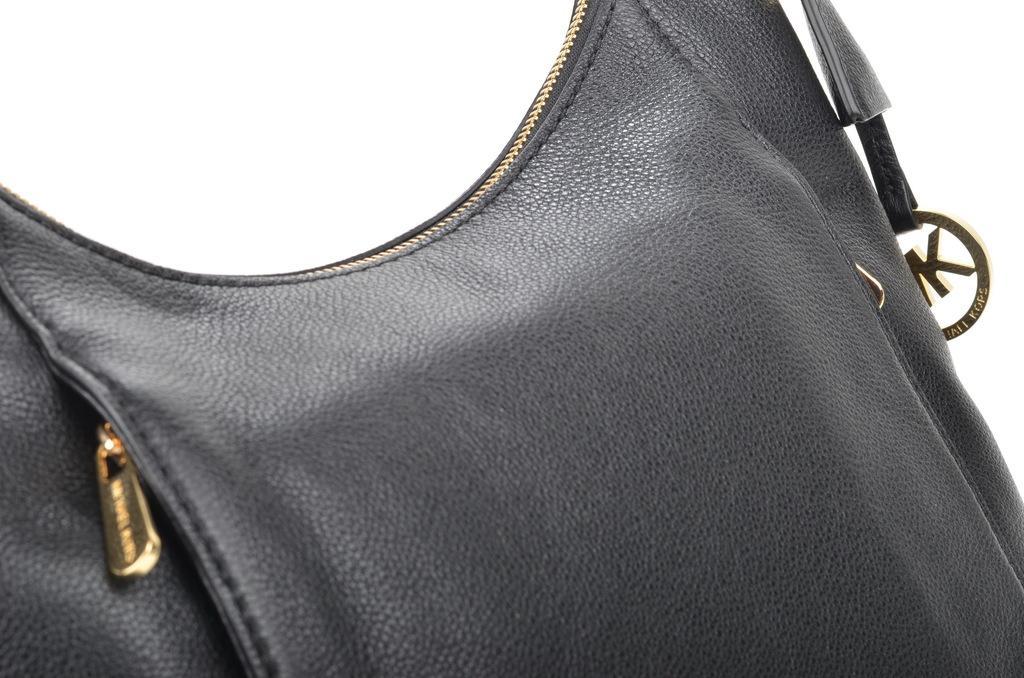Describe this image in one or two sentences. In this image we can see a black color leather bag. 